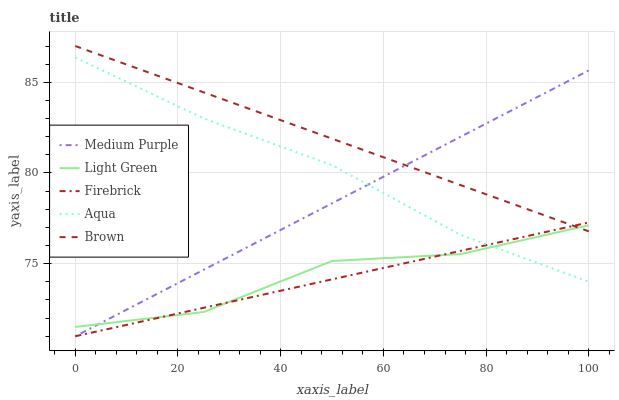Does Firebrick have the minimum area under the curve?
Answer yes or no. Yes. Does Brown have the maximum area under the curve?
Answer yes or no. Yes. Does Brown have the minimum area under the curve?
Answer yes or no. No. Does Firebrick have the maximum area under the curve?
Answer yes or no. No. Is Medium Purple the smoothest?
Answer yes or no. Yes. Is Light Green the roughest?
Answer yes or no. Yes. Is Brown the smoothest?
Answer yes or no. No. Is Brown the roughest?
Answer yes or no. No. Does Medium Purple have the lowest value?
Answer yes or no. Yes. Does Brown have the lowest value?
Answer yes or no. No. Does Brown have the highest value?
Answer yes or no. Yes. Does Firebrick have the highest value?
Answer yes or no. No. Is Aqua less than Brown?
Answer yes or no. Yes. Is Brown greater than Aqua?
Answer yes or no. Yes. Does Medium Purple intersect Light Green?
Answer yes or no. Yes. Is Medium Purple less than Light Green?
Answer yes or no. No. Is Medium Purple greater than Light Green?
Answer yes or no. No. Does Aqua intersect Brown?
Answer yes or no. No. 